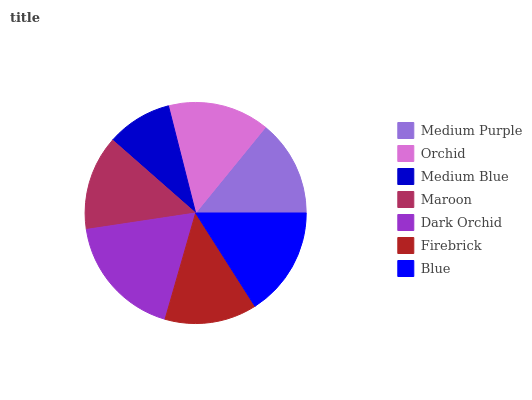Is Medium Blue the minimum?
Answer yes or no. Yes. Is Dark Orchid the maximum?
Answer yes or no. Yes. Is Orchid the minimum?
Answer yes or no. No. Is Orchid the maximum?
Answer yes or no. No. Is Orchid greater than Medium Purple?
Answer yes or no. Yes. Is Medium Purple less than Orchid?
Answer yes or no. Yes. Is Medium Purple greater than Orchid?
Answer yes or no. No. Is Orchid less than Medium Purple?
Answer yes or no. No. Is Medium Purple the high median?
Answer yes or no. Yes. Is Medium Purple the low median?
Answer yes or no. Yes. Is Blue the high median?
Answer yes or no. No. Is Orchid the low median?
Answer yes or no. No. 